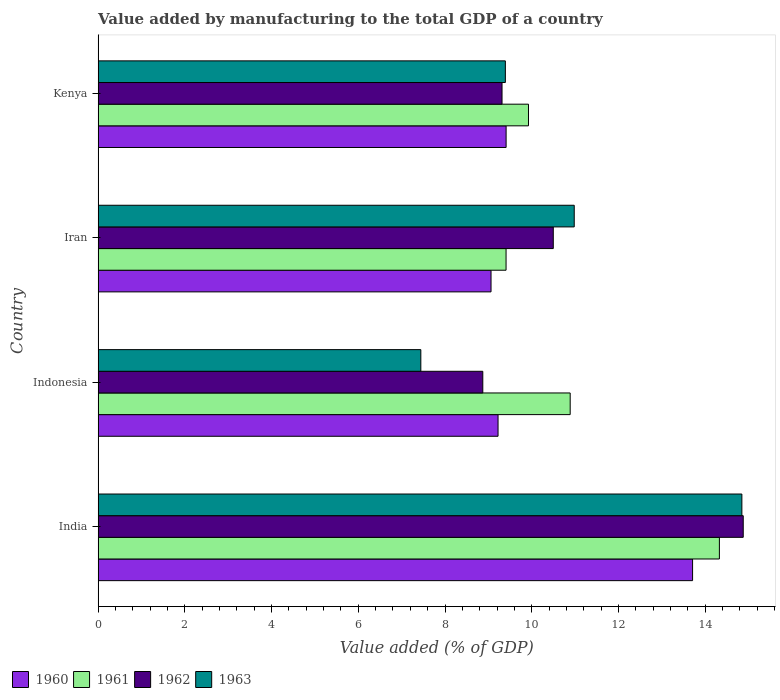How many groups of bars are there?
Offer a terse response. 4. Are the number of bars per tick equal to the number of legend labels?
Give a very brief answer. Yes. Are the number of bars on each tick of the Y-axis equal?
Make the answer very short. Yes. How many bars are there on the 4th tick from the bottom?
Provide a succinct answer. 4. What is the label of the 2nd group of bars from the top?
Offer a terse response. Iran. What is the value added by manufacturing to the total GDP in 1960 in Indonesia?
Provide a succinct answer. 9.22. Across all countries, what is the maximum value added by manufacturing to the total GDP in 1960?
Keep it short and to the point. 13.71. Across all countries, what is the minimum value added by manufacturing to the total GDP in 1962?
Your answer should be compact. 8.87. In which country was the value added by manufacturing to the total GDP in 1963 maximum?
Make the answer very short. India. What is the total value added by manufacturing to the total GDP in 1963 in the graph?
Your answer should be very brief. 42.66. What is the difference between the value added by manufacturing to the total GDP in 1963 in Iran and that in Kenya?
Give a very brief answer. 1.59. What is the difference between the value added by manufacturing to the total GDP in 1960 in India and the value added by manufacturing to the total GDP in 1962 in Iran?
Provide a succinct answer. 3.21. What is the average value added by manufacturing to the total GDP in 1961 per country?
Offer a terse response. 11.14. What is the difference between the value added by manufacturing to the total GDP in 1963 and value added by manufacturing to the total GDP in 1961 in Kenya?
Provide a succinct answer. -0.53. What is the ratio of the value added by manufacturing to the total GDP in 1960 in Indonesia to that in Kenya?
Keep it short and to the point. 0.98. Is the value added by manufacturing to the total GDP in 1962 in India less than that in Kenya?
Make the answer very short. No. Is the difference between the value added by manufacturing to the total GDP in 1963 in Iran and Kenya greater than the difference between the value added by manufacturing to the total GDP in 1961 in Iran and Kenya?
Keep it short and to the point. Yes. What is the difference between the highest and the second highest value added by manufacturing to the total GDP in 1962?
Keep it short and to the point. 4.38. What is the difference between the highest and the lowest value added by manufacturing to the total GDP in 1962?
Give a very brief answer. 6.01. In how many countries, is the value added by manufacturing to the total GDP in 1962 greater than the average value added by manufacturing to the total GDP in 1962 taken over all countries?
Offer a terse response. 1. Is the sum of the value added by manufacturing to the total GDP in 1963 in Iran and Kenya greater than the maximum value added by manufacturing to the total GDP in 1961 across all countries?
Offer a very short reply. Yes. Is it the case that in every country, the sum of the value added by manufacturing to the total GDP in 1961 and value added by manufacturing to the total GDP in 1962 is greater than the sum of value added by manufacturing to the total GDP in 1963 and value added by manufacturing to the total GDP in 1960?
Your answer should be compact. No. What does the 1st bar from the top in Iran represents?
Provide a short and direct response. 1963. Is it the case that in every country, the sum of the value added by manufacturing to the total GDP in 1962 and value added by manufacturing to the total GDP in 1963 is greater than the value added by manufacturing to the total GDP in 1961?
Your answer should be very brief. Yes. Are the values on the major ticks of X-axis written in scientific E-notation?
Ensure brevity in your answer.  No. Does the graph contain any zero values?
Give a very brief answer. No. Does the graph contain grids?
Offer a very short reply. No. How many legend labels are there?
Ensure brevity in your answer.  4. What is the title of the graph?
Ensure brevity in your answer.  Value added by manufacturing to the total GDP of a country. What is the label or title of the X-axis?
Make the answer very short. Value added (% of GDP). What is the label or title of the Y-axis?
Offer a very short reply. Country. What is the Value added (% of GDP) in 1960 in India?
Provide a succinct answer. 13.71. What is the Value added (% of GDP) in 1961 in India?
Provide a succinct answer. 14.33. What is the Value added (% of GDP) of 1962 in India?
Provide a succinct answer. 14.88. What is the Value added (% of GDP) of 1963 in India?
Provide a succinct answer. 14.85. What is the Value added (% of GDP) of 1960 in Indonesia?
Ensure brevity in your answer.  9.22. What is the Value added (% of GDP) in 1961 in Indonesia?
Give a very brief answer. 10.89. What is the Value added (% of GDP) of 1962 in Indonesia?
Give a very brief answer. 8.87. What is the Value added (% of GDP) in 1963 in Indonesia?
Your answer should be compact. 7.44. What is the Value added (% of GDP) in 1960 in Iran?
Ensure brevity in your answer.  9.06. What is the Value added (% of GDP) in 1961 in Iran?
Keep it short and to the point. 9.41. What is the Value added (% of GDP) of 1962 in Iran?
Give a very brief answer. 10.5. What is the Value added (% of GDP) of 1963 in Iran?
Keep it short and to the point. 10.98. What is the Value added (% of GDP) of 1960 in Kenya?
Keep it short and to the point. 9.41. What is the Value added (% of GDP) in 1961 in Kenya?
Give a very brief answer. 9.93. What is the Value added (% of GDP) in 1962 in Kenya?
Make the answer very short. 9.32. What is the Value added (% of GDP) of 1963 in Kenya?
Your answer should be compact. 9.39. Across all countries, what is the maximum Value added (% of GDP) of 1960?
Keep it short and to the point. 13.71. Across all countries, what is the maximum Value added (% of GDP) in 1961?
Your answer should be very brief. 14.33. Across all countries, what is the maximum Value added (% of GDP) of 1962?
Provide a short and direct response. 14.88. Across all countries, what is the maximum Value added (% of GDP) of 1963?
Your answer should be very brief. 14.85. Across all countries, what is the minimum Value added (% of GDP) in 1960?
Offer a very short reply. 9.06. Across all countries, what is the minimum Value added (% of GDP) of 1961?
Your answer should be very brief. 9.41. Across all countries, what is the minimum Value added (% of GDP) in 1962?
Make the answer very short. 8.87. Across all countries, what is the minimum Value added (% of GDP) in 1963?
Your response must be concise. 7.44. What is the total Value added (% of GDP) in 1960 in the graph?
Ensure brevity in your answer.  41.4. What is the total Value added (% of GDP) of 1961 in the graph?
Make the answer very short. 44.55. What is the total Value added (% of GDP) of 1962 in the graph?
Give a very brief answer. 43.56. What is the total Value added (% of GDP) in 1963 in the graph?
Your response must be concise. 42.66. What is the difference between the Value added (% of GDP) of 1960 in India and that in Indonesia?
Your response must be concise. 4.49. What is the difference between the Value added (% of GDP) of 1961 in India and that in Indonesia?
Your answer should be compact. 3.44. What is the difference between the Value added (% of GDP) in 1962 in India and that in Indonesia?
Provide a short and direct response. 6.01. What is the difference between the Value added (% of GDP) in 1963 in India and that in Indonesia?
Give a very brief answer. 7.4. What is the difference between the Value added (% of GDP) of 1960 in India and that in Iran?
Your answer should be compact. 4.65. What is the difference between the Value added (% of GDP) of 1961 in India and that in Iran?
Offer a terse response. 4.92. What is the difference between the Value added (% of GDP) in 1962 in India and that in Iran?
Give a very brief answer. 4.38. What is the difference between the Value added (% of GDP) of 1963 in India and that in Iran?
Provide a short and direct response. 3.87. What is the difference between the Value added (% of GDP) in 1960 in India and that in Kenya?
Your answer should be very brief. 4.3. What is the difference between the Value added (% of GDP) in 1961 in India and that in Kenya?
Give a very brief answer. 4.4. What is the difference between the Value added (% of GDP) in 1962 in India and that in Kenya?
Ensure brevity in your answer.  5.56. What is the difference between the Value added (% of GDP) of 1963 in India and that in Kenya?
Provide a succinct answer. 5.45. What is the difference between the Value added (% of GDP) of 1960 in Indonesia and that in Iran?
Ensure brevity in your answer.  0.16. What is the difference between the Value added (% of GDP) in 1961 in Indonesia and that in Iran?
Your response must be concise. 1.48. What is the difference between the Value added (% of GDP) of 1962 in Indonesia and that in Iran?
Offer a terse response. -1.63. What is the difference between the Value added (% of GDP) of 1963 in Indonesia and that in Iran?
Make the answer very short. -3.54. What is the difference between the Value added (% of GDP) in 1960 in Indonesia and that in Kenya?
Offer a very short reply. -0.19. What is the difference between the Value added (% of GDP) of 1961 in Indonesia and that in Kenya?
Offer a terse response. 0.96. What is the difference between the Value added (% of GDP) of 1962 in Indonesia and that in Kenya?
Your response must be concise. -0.44. What is the difference between the Value added (% of GDP) in 1963 in Indonesia and that in Kenya?
Give a very brief answer. -1.95. What is the difference between the Value added (% of GDP) of 1960 in Iran and that in Kenya?
Give a very brief answer. -0.35. What is the difference between the Value added (% of GDP) in 1961 in Iran and that in Kenya?
Offer a very short reply. -0.52. What is the difference between the Value added (% of GDP) of 1962 in Iran and that in Kenya?
Keep it short and to the point. 1.18. What is the difference between the Value added (% of GDP) in 1963 in Iran and that in Kenya?
Make the answer very short. 1.59. What is the difference between the Value added (% of GDP) in 1960 in India and the Value added (% of GDP) in 1961 in Indonesia?
Offer a terse response. 2.82. What is the difference between the Value added (% of GDP) of 1960 in India and the Value added (% of GDP) of 1962 in Indonesia?
Provide a succinct answer. 4.84. What is the difference between the Value added (% of GDP) of 1960 in India and the Value added (% of GDP) of 1963 in Indonesia?
Your answer should be very brief. 6.27. What is the difference between the Value added (% of GDP) of 1961 in India and the Value added (% of GDP) of 1962 in Indonesia?
Your response must be concise. 5.46. What is the difference between the Value added (% of GDP) of 1961 in India and the Value added (% of GDP) of 1963 in Indonesia?
Keep it short and to the point. 6.89. What is the difference between the Value added (% of GDP) in 1962 in India and the Value added (% of GDP) in 1963 in Indonesia?
Ensure brevity in your answer.  7.44. What is the difference between the Value added (% of GDP) in 1960 in India and the Value added (% of GDP) in 1961 in Iran?
Make the answer very short. 4.3. What is the difference between the Value added (% of GDP) in 1960 in India and the Value added (% of GDP) in 1962 in Iran?
Your response must be concise. 3.21. What is the difference between the Value added (% of GDP) in 1960 in India and the Value added (% of GDP) in 1963 in Iran?
Provide a succinct answer. 2.73. What is the difference between the Value added (% of GDP) in 1961 in India and the Value added (% of GDP) in 1962 in Iran?
Offer a very short reply. 3.83. What is the difference between the Value added (% of GDP) of 1961 in India and the Value added (% of GDP) of 1963 in Iran?
Make the answer very short. 3.35. What is the difference between the Value added (% of GDP) of 1962 in India and the Value added (% of GDP) of 1963 in Iran?
Your answer should be very brief. 3.9. What is the difference between the Value added (% of GDP) of 1960 in India and the Value added (% of GDP) of 1961 in Kenya?
Offer a very short reply. 3.78. What is the difference between the Value added (% of GDP) of 1960 in India and the Value added (% of GDP) of 1962 in Kenya?
Offer a very short reply. 4.39. What is the difference between the Value added (% of GDP) of 1960 in India and the Value added (% of GDP) of 1963 in Kenya?
Provide a succinct answer. 4.32. What is the difference between the Value added (% of GDP) in 1961 in India and the Value added (% of GDP) in 1962 in Kenya?
Offer a terse response. 5.01. What is the difference between the Value added (% of GDP) in 1961 in India and the Value added (% of GDP) in 1963 in Kenya?
Offer a terse response. 4.94. What is the difference between the Value added (% of GDP) of 1962 in India and the Value added (% of GDP) of 1963 in Kenya?
Give a very brief answer. 5.49. What is the difference between the Value added (% of GDP) in 1960 in Indonesia and the Value added (% of GDP) in 1961 in Iran?
Provide a short and direct response. -0.18. What is the difference between the Value added (% of GDP) of 1960 in Indonesia and the Value added (% of GDP) of 1962 in Iran?
Give a very brief answer. -1.27. What is the difference between the Value added (% of GDP) in 1960 in Indonesia and the Value added (% of GDP) in 1963 in Iran?
Give a very brief answer. -1.76. What is the difference between the Value added (% of GDP) of 1961 in Indonesia and the Value added (% of GDP) of 1962 in Iran?
Provide a short and direct response. 0.39. What is the difference between the Value added (% of GDP) in 1961 in Indonesia and the Value added (% of GDP) in 1963 in Iran?
Make the answer very short. -0.09. What is the difference between the Value added (% of GDP) of 1962 in Indonesia and the Value added (% of GDP) of 1963 in Iran?
Offer a terse response. -2.11. What is the difference between the Value added (% of GDP) of 1960 in Indonesia and the Value added (% of GDP) of 1961 in Kenya?
Provide a succinct answer. -0.7. What is the difference between the Value added (% of GDP) in 1960 in Indonesia and the Value added (% of GDP) in 1962 in Kenya?
Keep it short and to the point. -0.09. What is the difference between the Value added (% of GDP) of 1960 in Indonesia and the Value added (% of GDP) of 1963 in Kenya?
Your answer should be compact. -0.17. What is the difference between the Value added (% of GDP) of 1961 in Indonesia and the Value added (% of GDP) of 1962 in Kenya?
Your answer should be compact. 1.57. What is the difference between the Value added (% of GDP) of 1961 in Indonesia and the Value added (% of GDP) of 1963 in Kenya?
Offer a terse response. 1.5. What is the difference between the Value added (% of GDP) in 1962 in Indonesia and the Value added (% of GDP) in 1963 in Kenya?
Ensure brevity in your answer.  -0.52. What is the difference between the Value added (% of GDP) of 1960 in Iran and the Value added (% of GDP) of 1961 in Kenya?
Provide a short and direct response. -0.86. What is the difference between the Value added (% of GDP) in 1960 in Iran and the Value added (% of GDP) in 1962 in Kenya?
Offer a terse response. -0.25. What is the difference between the Value added (% of GDP) in 1960 in Iran and the Value added (% of GDP) in 1963 in Kenya?
Offer a terse response. -0.33. What is the difference between the Value added (% of GDP) in 1961 in Iran and the Value added (% of GDP) in 1962 in Kenya?
Keep it short and to the point. 0.09. What is the difference between the Value added (% of GDP) of 1961 in Iran and the Value added (% of GDP) of 1963 in Kenya?
Your answer should be compact. 0.02. What is the difference between the Value added (% of GDP) of 1962 in Iran and the Value added (% of GDP) of 1963 in Kenya?
Your response must be concise. 1.11. What is the average Value added (% of GDP) of 1960 per country?
Provide a short and direct response. 10.35. What is the average Value added (% of GDP) of 1961 per country?
Offer a very short reply. 11.14. What is the average Value added (% of GDP) of 1962 per country?
Your answer should be compact. 10.89. What is the average Value added (% of GDP) in 1963 per country?
Ensure brevity in your answer.  10.67. What is the difference between the Value added (% of GDP) in 1960 and Value added (% of GDP) in 1961 in India?
Give a very brief answer. -0.62. What is the difference between the Value added (% of GDP) of 1960 and Value added (% of GDP) of 1962 in India?
Your answer should be very brief. -1.17. What is the difference between the Value added (% of GDP) in 1960 and Value added (% of GDP) in 1963 in India?
Ensure brevity in your answer.  -1.14. What is the difference between the Value added (% of GDP) in 1961 and Value added (% of GDP) in 1962 in India?
Give a very brief answer. -0.55. What is the difference between the Value added (% of GDP) in 1961 and Value added (% of GDP) in 1963 in India?
Ensure brevity in your answer.  -0.52. What is the difference between the Value added (% of GDP) in 1962 and Value added (% of GDP) in 1963 in India?
Provide a succinct answer. 0.03. What is the difference between the Value added (% of GDP) of 1960 and Value added (% of GDP) of 1961 in Indonesia?
Keep it short and to the point. -1.66. What is the difference between the Value added (% of GDP) in 1960 and Value added (% of GDP) in 1962 in Indonesia?
Offer a terse response. 0.35. What is the difference between the Value added (% of GDP) in 1960 and Value added (% of GDP) in 1963 in Indonesia?
Offer a terse response. 1.78. What is the difference between the Value added (% of GDP) of 1961 and Value added (% of GDP) of 1962 in Indonesia?
Offer a very short reply. 2.02. What is the difference between the Value added (% of GDP) in 1961 and Value added (% of GDP) in 1963 in Indonesia?
Your answer should be compact. 3.44. What is the difference between the Value added (% of GDP) in 1962 and Value added (% of GDP) in 1963 in Indonesia?
Keep it short and to the point. 1.43. What is the difference between the Value added (% of GDP) in 1960 and Value added (% of GDP) in 1961 in Iran?
Provide a succinct answer. -0.35. What is the difference between the Value added (% of GDP) in 1960 and Value added (% of GDP) in 1962 in Iran?
Provide a succinct answer. -1.44. What is the difference between the Value added (% of GDP) in 1960 and Value added (% of GDP) in 1963 in Iran?
Keep it short and to the point. -1.92. What is the difference between the Value added (% of GDP) of 1961 and Value added (% of GDP) of 1962 in Iran?
Offer a very short reply. -1.09. What is the difference between the Value added (% of GDP) in 1961 and Value added (% of GDP) in 1963 in Iran?
Offer a terse response. -1.57. What is the difference between the Value added (% of GDP) in 1962 and Value added (% of GDP) in 1963 in Iran?
Make the answer very short. -0.48. What is the difference between the Value added (% of GDP) in 1960 and Value added (% of GDP) in 1961 in Kenya?
Your answer should be compact. -0.52. What is the difference between the Value added (% of GDP) of 1960 and Value added (% of GDP) of 1962 in Kenya?
Offer a terse response. 0.09. What is the difference between the Value added (% of GDP) of 1960 and Value added (% of GDP) of 1963 in Kenya?
Provide a short and direct response. 0.02. What is the difference between the Value added (% of GDP) in 1961 and Value added (% of GDP) in 1962 in Kenya?
Ensure brevity in your answer.  0.61. What is the difference between the Value added (% of GDP) of 1961 and Value added (% of GDP) of 1963 in Kenya?
Offer a terse response. 0.53. What is the difference between the Value added (% of GDP) in 1962 and Value added (% of GDP) in 1963 in Kenya?
Your answer should be compact. -0.08. What is the ratio of the Value added (% of GDP) in 1960 in India to that in Indonesia?
Give a very brief answer. 1.49. What is the ratio of the Value added (% of GDP) in 1961 in India to that in Indonesia?
Offer a very short reply. 1.32. What is the ratio of the Value added (% of GDP) in 1962 in India to that in Indonesia?
Give a very brief answer. 1.68. What is the ratio of the Value added (% of GDP) in 1963 in India to that in Indonesia?
Keep it short and to the point. 1.99. What is the ratio of the Value added (% of GDP) of 1960 in India to that in Iran?
Your response must be concise. 1.51. What is the ratio of the Value added (% of GDP) of 1961 in India to that in Iran?
Keep it short and to the point. 1.52. What is the ratio of the Value added (% of GDP) in 1962 in India to that in Iran?
Provide a short and direct response. 1.42. What is the ratio of the Value added (% of GDP) of 1963 in India to that in Iran?
Make the answer very short. 1.35. What is the ratio of the Value added (% of GDP) of 1960 in India to that in Kenya?
Provide a short and direct response. 1.46. What is the ratio of the Value added (% of GDP) of 1961 in India to that in Kenya?
Ensure brevity in your answer.  1.44. What is the ratio of the Value added (% of GDP) in 1962 in India to that in Kenya?
Offer a terse response. 1.6. What is the ratio of the Value added (% of GDP) of 1963 in India to that in Kenya?
Offer a terse response. 1.58. What is the ratio of the Value added (% of GDP) in 1960 in Indonesia to that in Iran?
Give a very brief answer. 1.02. What is the ratio of the Value added (% of GDP) of 1961 in Indonesia to that in Iran?
Your answer should be compact. 1.16. What is the ratio of the Value added (% of GDP) in 1962 in Indonesia to that in Iran?
Provide a succinct answer. 0.85. What is the ratio of the Value added (% of GDP) in 1963 in Indonesia to that in Iran?
Ensure brevity in your answer.  0.68. What is the ratio of the Value added (% of GDP) in 1960 in Indonesia to that in Kenya?
Your answer should be very brief. 0.98. What is the ratio of the Value added (% of GDP) of 1961 in Indonesia to that in Kenya?
Provide a succinct answer. 1.1. What is the ratio of the Value added (% of GDP) in 1963 in Indonesia to that in Kenya?
Your answer should be compact. 0.79. What is the ratio of the Value added (% of GDP) of 1961 in Iran to that in Kenya?
Give a very brief answer. 0.95. What is the ratio of the Value added (% of GDP) in 1962 in Iran to that in Kenya?
Your answer should be very brief. 1.13. What is the ratio of the Value added (% of GDP) in 1963 in Iran to that in Kenya?
Offer a terse response. 1.17. What is the difference between the highest and the second highest Value added (% of GDP) of 1960?
Offer a very short reply. 4.3. What is the difference between the highest and the second highest Value added (% of GDP) in 1961?
Keep it short and to the point. 3.44. What is the difference between the highest and the second highest Value added (% of GDP) of 1962?
Offer a terse response. 4.38. What is the difference between the highest and the second highest Value added (% of GDP) in 1963?
Your answer should be very brief. 3.87. What is the difference between the highest and the lowest Value added (% of GDP) of 1960?
Give a very brief answer. 4.65. What is the difference between the highest and the lowest Value added (% of GDP) of 1961?
Offer a very short reply. 4.92. What is the difference between the highest and the lowest Value added (% of GDP) of 1962?
Offer a very short reply. 6.01. What is the difference between the highest and the lowest Value added (% of GDP) of 1963?
Your response must be concise. 7.4. 